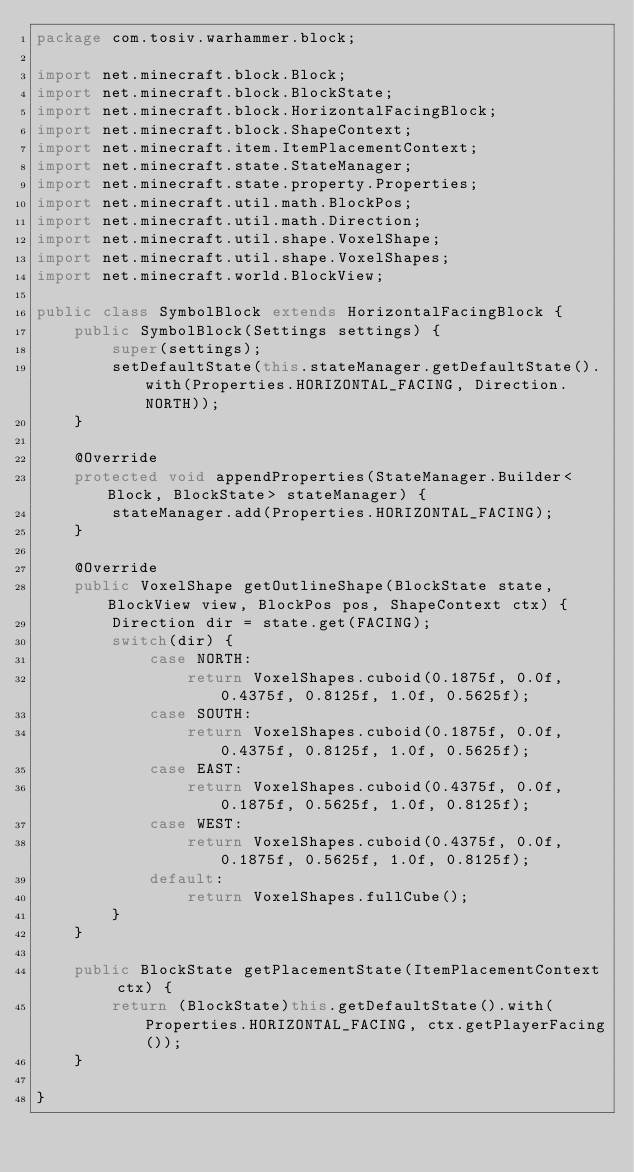<code> <loc_0><loc_0><loc_500><loc_500><_Java_>package com.tosiv.warhammer.block;

import net.minecraft.block.Block;
import net.minecraft.block.BlockState;
import net.minecraft.block.HorizontalFacingBlock;
import net.minecraft.block.ShapeContext;
import net.minecraft.item.ItemPlacementContext;
import net.minecraft.state.StateManager;
import net.minecraft.state.property.Properties;
import net.minecraft.util.math.BlockPos;
import net.minecraft.util.math.Direction;
import net.minecraft.util.shape.VoxelShape;
import net.minecraft.util.shape.VoxelShapes;
import net.minecraft.world.BlockView;

public class SymbolBlock extends HorizontalFacingBlock {
    public SymbolBlock(Settings settings) {
        super(settings);
        setDefaultState(this.stateManager.getDefaultState().with(Properties.HORIZONTAL_FACING, Direction.NORTH));
    }

    @Override
    protected void appendProperties(StateManager.Builder<Block, BlockState> stateManager) {
        stateManager.add(Properties.HORIZONTAL_FACING);
    }

    @Override
    public VoxelShape getOutlineShape(BlockState state, BlockView view, BlockPos pos, ShapeContext ctx) {
        Direction dir = state.get(FACING);
        switch(dir) {
            case NORTH:
                return VoxelShapes.cuboid(0.1875f, 0.0f, 0.4375f, 0.8125f, 1.0f, 0.5625f);
            case SOUTH:
                return VoxelShapes.cuboid(0.1875f, 0.0f, 0.4375f, 0.8125f, 1.0f, 0.5625f);
            case EAST:
                return VoxelShapes.cuboid(0.4375f, 0.0f, 0.1875f, 0.5625f, 1.0f, 0.8125f);
            case WEST:
                return VoxelShapes.cuboid(0.4375f, 0.0f, 0.1875f, 0.5625f, 1.0f, 0.8125f);
            default:
                return VoxelShapes.fullCube();
        }
    }

    public BlockState getPlacementState(ItemPlacementContext ctx) {
        return (BlockState)this.getDefaultState().with(Properties.HORIZONTAL_FACING, ctx.getPlayerFacing());
    }

}</code> 